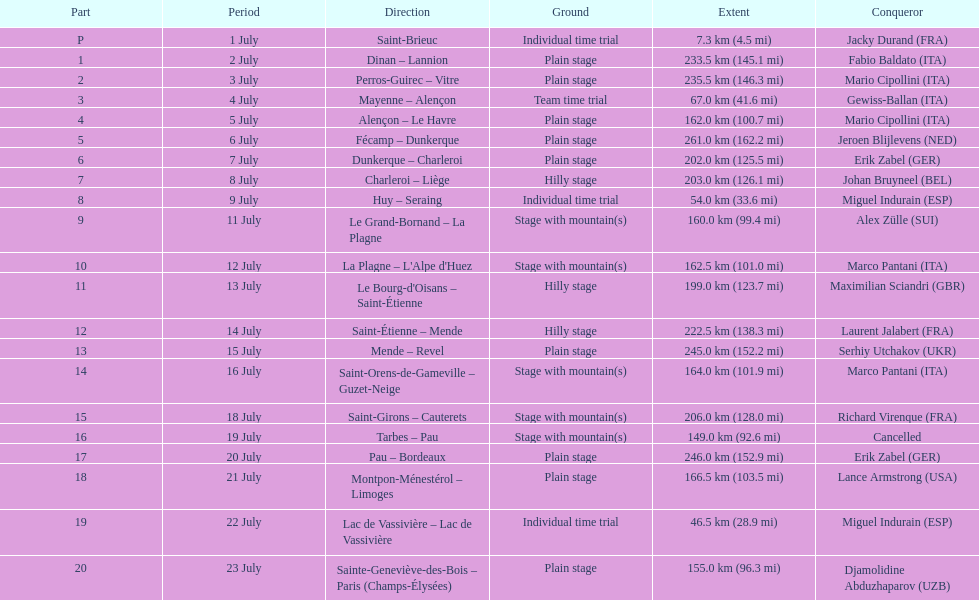Which paths had a minimum distance of 100 km? Dinan - Lannion, Perros-Guirec - Vitre, Alençon - Le Havre, Fécamp - Dunkerque, Dunkerque - Charleroi, Charleroi - Liège, Le Grand-Bornand - La Plagne, La Plagne - L'Alpe d'Huez, Le Bourg-d'Oisans - Saint-Étienne, Saint-Étienne - Mende, Mende - Revel, Saint-Orens-de-Gameville - Guzet-Neige, Saint-Girons - Cauterets, Tarbes - Pau, Pau - Bordeaux, Montpon-Ménestérol - Limoges, Sainte-Geneviève-des-Bois - Paris (Champs-Élysées). 